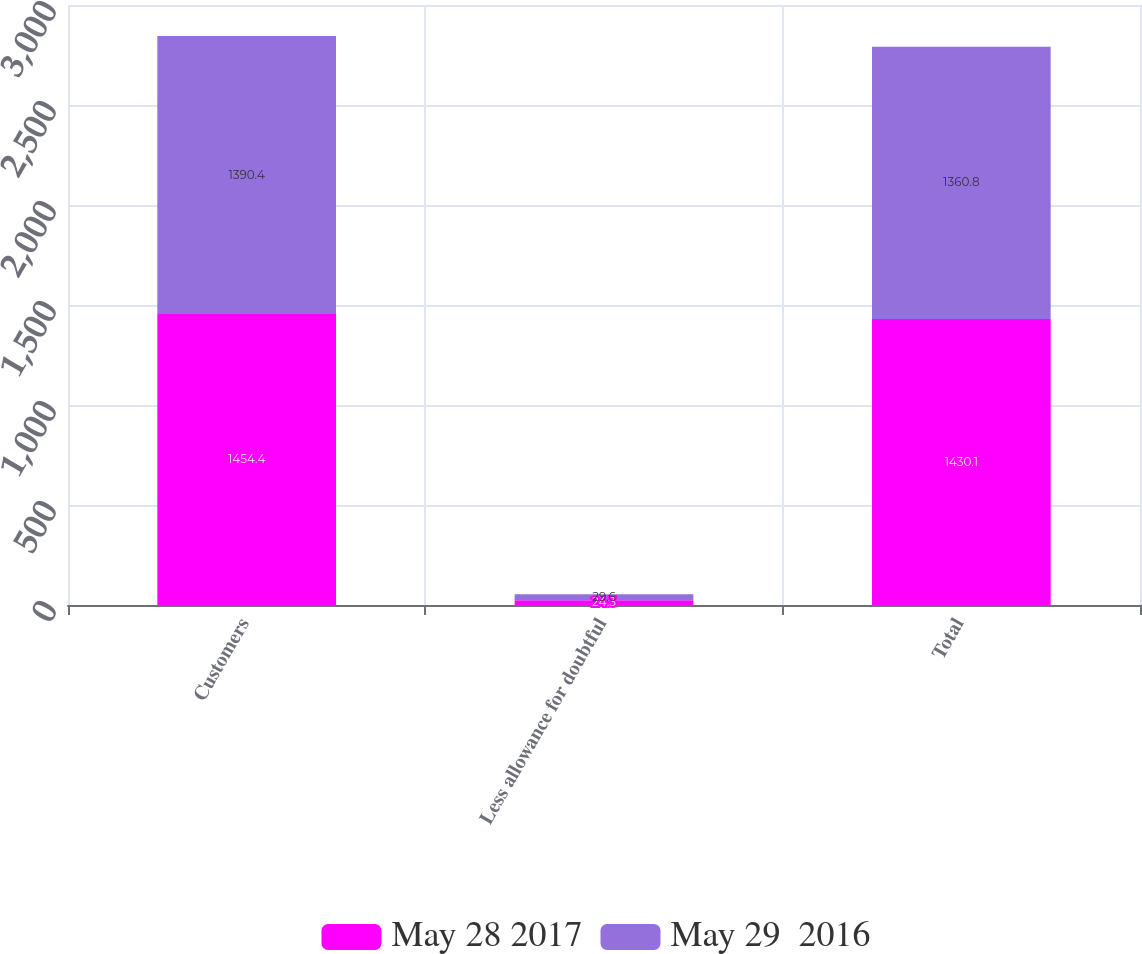Convert chart to OTSL. <chart><loc_0><loc_0><loc_500><loc_500><stacked_bar_chart><ecel><fcel>Customers<fcel>Less allowance for doubtful<fcel>Total<nl><fcel>May 28 2017<fcel>1454.4<fcel>24.3<fcel>1430.1<nl><fcel>May 29  2016<fcel>1390.4<fcel>29.6<fcel>1360.8<nl></chart> 